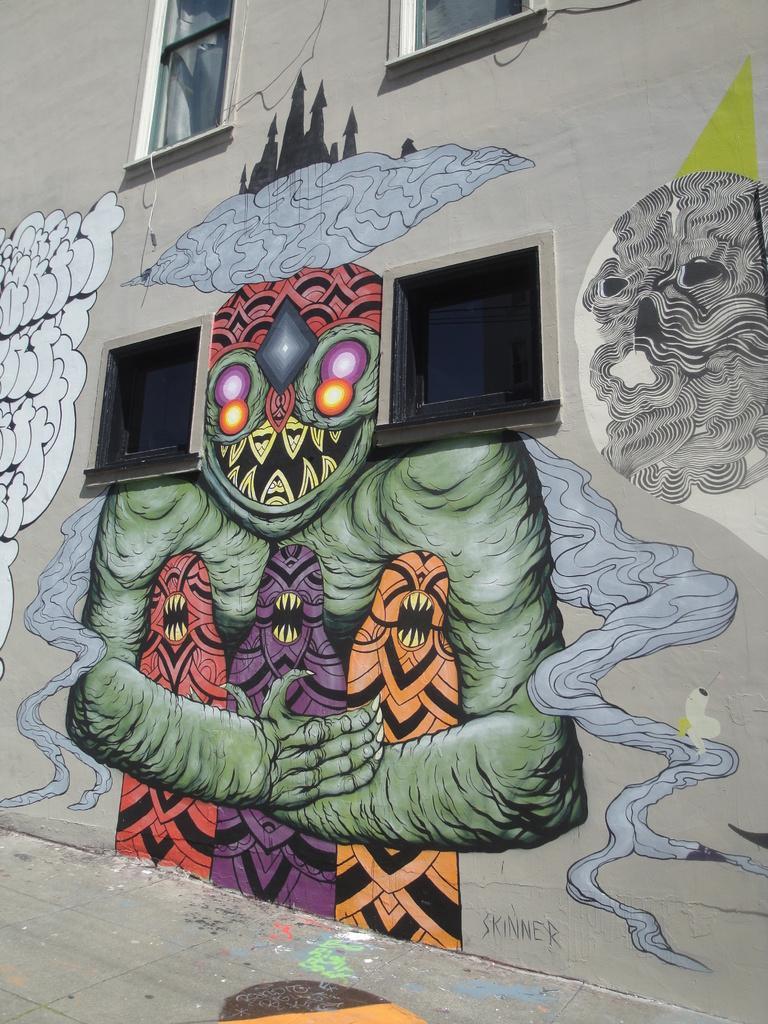How would you summarize this image in a sentence or two? In this image I can see there is a painting of monsters on the wall of a building and there are glass windows. 